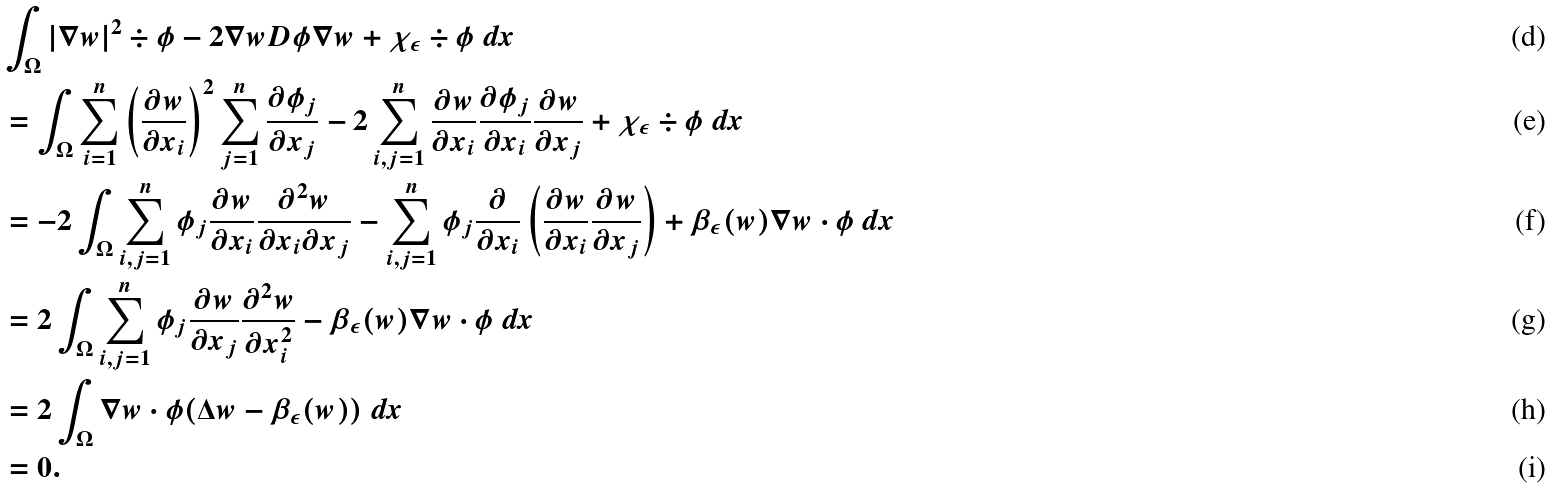Convert formula to latex. <formula><loc_0><loc_0><loc_500><loc_500>& \int _ { \Omega } | \nabla w | ^ { 2 } \div \phi - 2 \nabla w D \phi \nabla w + \chi _ { \epsilon } \div \phi \ d x \\ & = \int _ { \Omega } \sum _ { i = 1 } ^ { n } \left ( \frac { \partial w } { \partial x _ { i } } \right ) ^ { 2 } \sum _ { j = 1 } ^ { n } \frac { \partial \phi _ { j } } { \partial x _ { j } } - 2 \sum _ { i , j = 1 } ^ { n } \frac { \partial w } { \partial x _ { i } } \frac { \partial \phi _ { j } } { \partial x _ { i } } \frac { \partial w } { \partial x _ { j } } + \chi _ { \epsilon } \div \phi \ d x \\ & = - 2 \int _ { \Omega } \sum _ { i , j = 1 } ^ { n } \phi _ { j } \frac { \partial w } { \partial x _ { i } } \frac { \partial ^ { 2 } w } { \partial x _ { i } \partial x _ { j } } - \sum _ { i , j = 1 } ^ { n } \phi _ { j } \frac { \partial } { \partial x _ { i } } \left ( \frac { \partial w } { \partial x _ { i } } \frac { \partial w } { \partial x _ { j } } \right ) + \beta _ { \epsilon } ( w ) \nabla w \cdot \phi \ d x \\ & = 2 \int _ { \Omega } \sum _ { i , j = 1 } ^ { n } \phi _ { j } \frac { \partial w } { \partial x _ { j } } \frac { \partial ^ { 2 } w } { \partial x _ { i } ^ { 2 } } - \beta _ { \epsilon } ( w ) \nabla w \cdot \phi \ d x \\ & = 2 \int _ { \Omega } \nabla w \cdot \phi ( \Delta w - \beta _ { \epsilon } ( w ) ) \ d x \\ & = 0 .</formula> 